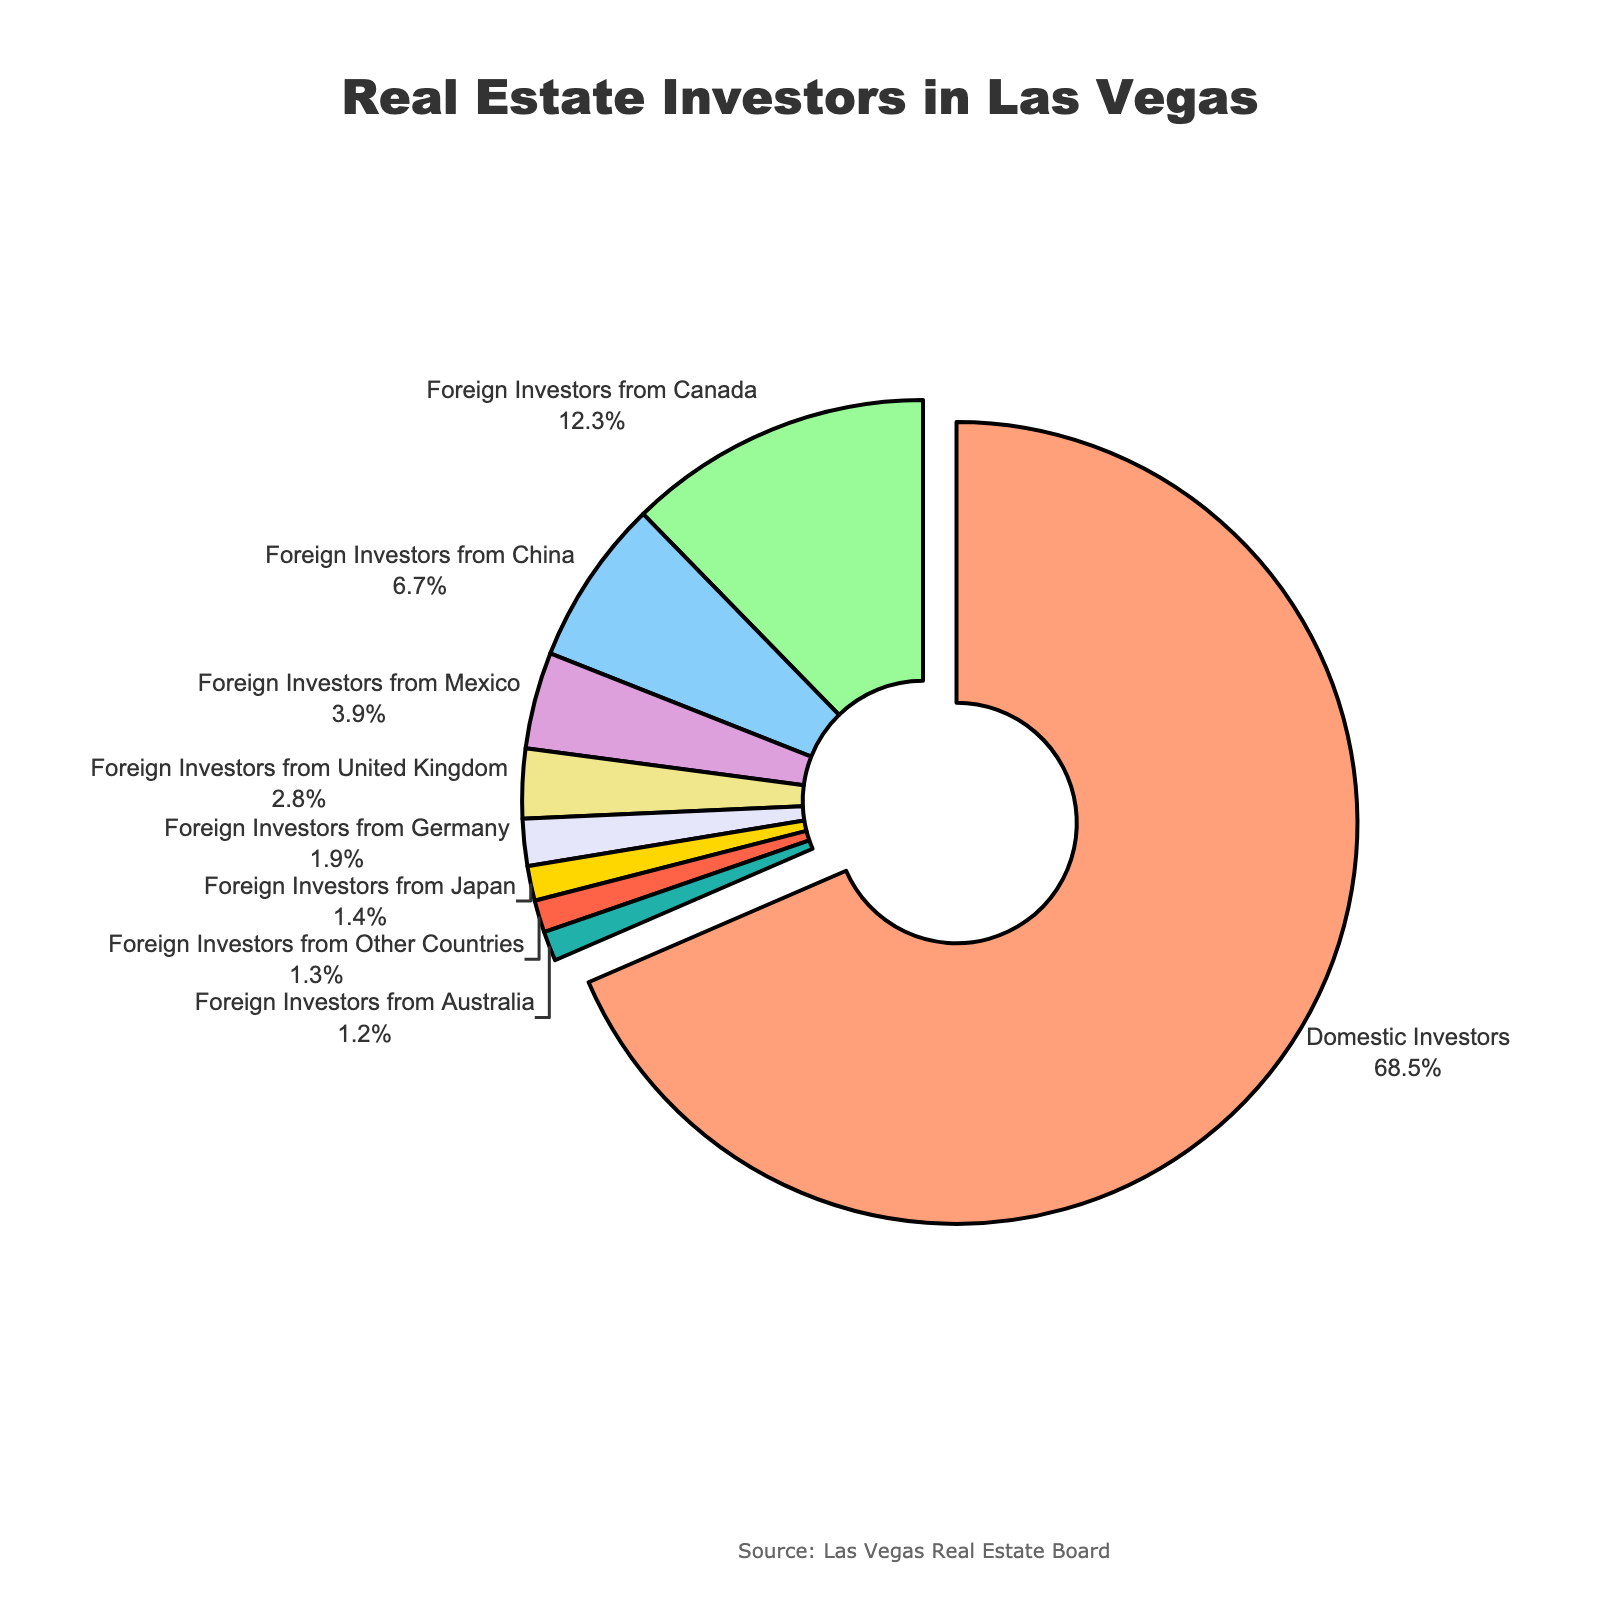Which investor group has the largest proportion? The pie chart shows that Domestic Investors have the largest proportion at 68.5%.
Answer: Domestic Investors What is the combined proportion of foreign investors from Canada and China? According to the pie chart, Canadian investors are 12.3% and Chinese investors are 6.7%. The combined proportion is 12.3% + 6.7% = 19%.
Answer: 19% Which foreign country has the smallest proportion of real estate investors in Las Vegas? According to the chart, Japan has the smallest proportion at 1.4%.
Answer: Japan Are there more investors from the United Kingdom or Germany? The pie chart shows 2.8% investors from the United Kingdom and 1.9% from Germany. Hence, there are more investors from the United Kingdom.
Answer: United Kingdom What is the proportion of all foreign investors combined? Adding all percentages of foreign investors: 12.3% (Canada) + 6.7% (China) + 3.9% (Mexico) + 2.8% (UK) + 1.9% (Germany) + 1.4% (Japan) + 1.2% (Australia) + 1.3% (Other Countries) = 31.5%.
Answer: 31.5% Which color represents the Domestic Investors? The first segment of the chart which pulls out slightly represents Domestic Investors, and it's shown in a light salmon color.
Answer: Light Salmon Which two foreign investor groups have a combined proportion closest to 10%? The pie chart shows Foreign Investors from China at 6.7% and from Mexico at 3.9%. Their combined proportion is 6.7% + 3.9% = 10.6%, which is closest to 10%.
Answer: China and Mexico What is the difference in proportion between Domestic Investors and Foreign Investors from Japan? Domestic Investors are 68.5%, and Foreign Investors from Japan are 1.4%. The difference is 68.5% - 1.4% = 67.1%.
Answer: 67.1% What portion of the chart does Australian investors occupy relative to German investors? Australian investors are 1.2%, and German investors are 1.9%. The ratio of Australian to German investors is 1.2%/1.9% ≈ 0.63.
Answer: 0.63 